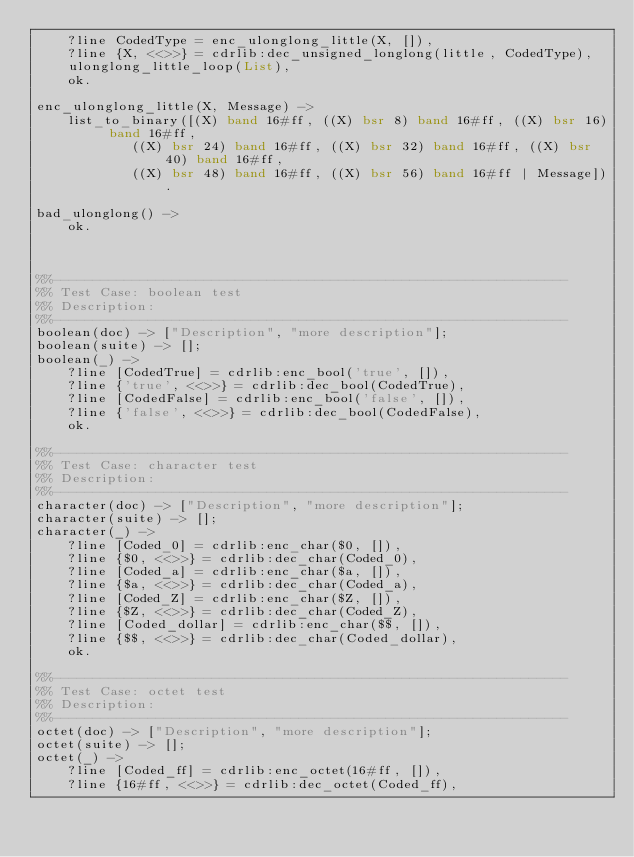Convert code to text. <code><loc_0><loc_0><loc_500><loc_500><_Erlang_>    ?line CodedType = enc_ulonglong_little(X, []),
    ?line {X, <<>>} = cdrlib:dec_unsigned_longlong(little, CodedType),
    ulonglong_little_loop(List),
    ok.

enc_ulonglong_little(X, Message) -> 
    list_to_binary([(X) band 16#ff, ((X) bsr 8) band 16#ff, ((X) bsr 16) band 16#ff,
		    ((X) bsr 24) band 16#ff, ((X) bsr 32) band 16#ff, ((X) bsr 40) band 16#ff,
		    ((X) bsr 48) band 16#ff, ((X) bsr 56) band 16#ff | Message]).

bad_ulonglong() ->
    ok.



%%-----------------------------------------------------------------
%% Test Case: boolean test
%% Description: 
%%-----------------------------------------------------------------
boolean(doc) -> ["Description", "more description"];
boolean(suite) -> [];
boolean(_) ->
    ?line [CodedTrue] = cdrlib:enc_bool('true', []),
    ?line {'true', <<>>} = cdrlib:dec_bool(CodedTrue),
    ?line [CodedFalse] = cdrlib:enc_bool('false', []),
    ?line {'false', <<>>} = cdrlib:dec_bool(CodedFalse),
    ok.

%%-----------------------------------------------------------------
%% Test Case: character test
%% Description: 
%%-----------------------------------------------------------------
character(doc) -> ["Description", "more description"];
character(suite) -> [];
character(_) ->
    ?line [Coded_0] = cdrlib:enc_char($0, []),
    ?line {$0, <<>>} = cdrlib:dec_char(Coded_0),
    ?line [Coded_a] = cdrlib:enc_char($a, []),
    ?line {$a, <<>>} = cdrlib:dec_char(Coded_a),
    ?line [Coded_Z] = cdrlib:enc_char($Z, []),
    ?line {$Z, <<>>} = cdrlib:dec_char(Coded_Z),
    ?line [Coded_dollar] = cdrlib:enc_char($$, []),
    ?line {$$, <<>>} = cdrlib:dec_char(Coded_dollar),
    ok.

%%-----------------------------------------------------------------
%% Test Case: octet test
%% Description: 
%%-----------------------------------------------------------------
octet(doc) -> ["Description", "more description"];
octet(suite) -> [];
octet(_) ->
    ?line [Coded_ff] = cdrlib:enc_octet(16#ff, []),
    ?line {16#ff, <<>>} = cdrlib:dec_octet(Coded_ff),</code> 